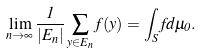<formula> <loc_0><loc_0><loc_500><loc_500>\lim _ { n \rightarrow \infty } \frac { 1 } { | E _ { n } | } \sum _ { y \in E _ { n } } f ( y ) = \int _ { S } f d \mu _ { 0 } .</formula> 